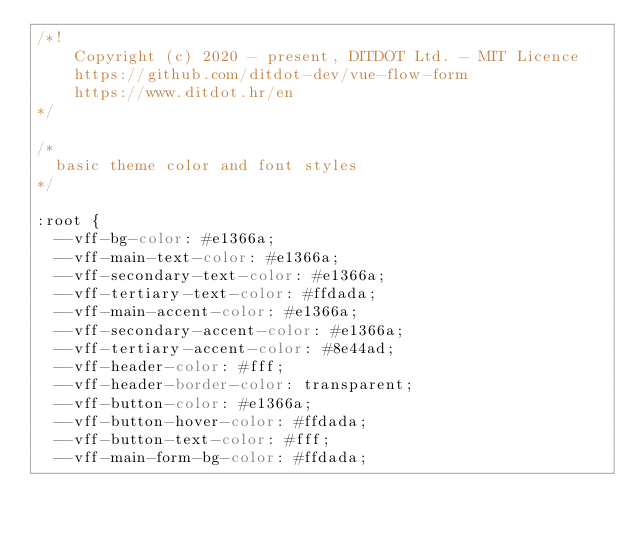Convert code to text. <code><loc_0><loc_0><loc_500><loc_500><_CSS_>/*!
    Copyright (c) 2020 - present, DITDOT Ltd. - MIT Licence
    https://github.com/ditdot-dev/vue-flow-form
    https://www.ditdot.hr/en
*/

/*
  basic theme color and font styles
*/

:root {
  --vff-bg-color: #e1366a;
  --vff-main-text-color: #e1366a;
  --vff-secondary-text-color: #e1366a;
  --vff-tertiary-text-color: #ffdada;
  --vff-main-accent-color: #e1366a;
  --vff-secondary-accent-color: #e1366a;
  --vff-tertiary-accent-color: #8e44ad;
  --vff-header-color: #fff;
  --vff-header-border-color: transparent;
  --vff-button-color: #e1366a;
  --vff-button-hover-color: #ffdada;
  --vff-button-text-color: #fff;
  --vff-main-form-bg-color: #ffdada;</code> 